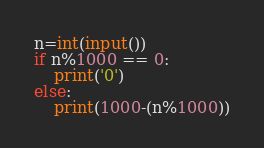<code> <loc_0><loc_0><loc_500><loc_500><_Python_>n=int(input())
if n%1000 == 0:
    print('0')
else:
    print(1000-(n%1000))</code> 